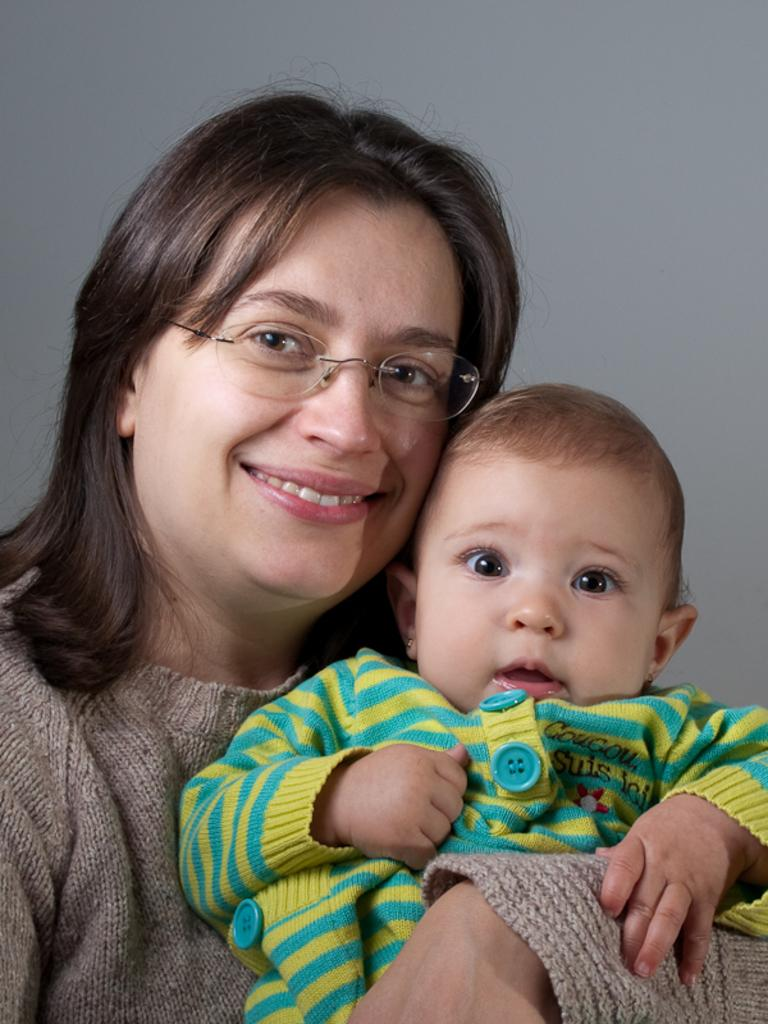Who is the main subject in the image? There is a woman in the image. What is the woman holding in the image? The woman is holding a baby. What can be seen in the background of the image? There is a wall in the background of the image. What type of coat is the baby wearing in the image? There is no coat visible on the baby in the image, as the baby is not wearing any clothing. 